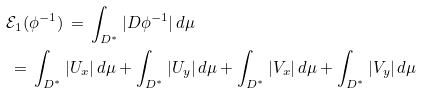Convert formula to latex. <formula><loc_0><loc_0><loc_500><loc_500>& \mathcal { E } _ { 1 } ( \phi ^ { - 1 } ) \, = \, \int _ { D ^ { * } } | D \phi ^ { - 1 } | \, d \mu \\ & \, = \, \int _ { D ^ { * } } | U _ { x } | \, d \mu + \int _ { D ^ { * } } | U _ { y } | \, d \mu + \int _ { D ^ { * } } | V _ { x } | \, d \mu + \int _ { D ^ { * } } | V _ { y } | \, d \mu</formula> 